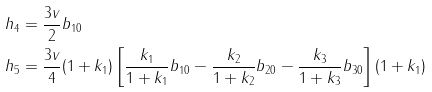Convert formula to latex. <formula><loc_0><loc_0><loc_500><loc_500>h _ { 4 } & = \frac { 3 v } { 2 } b _ { 1 0 } \\ h _ { 5 } & = \frac { 3 v } { 4 } ( 1 + k _ { 1 } ) \left [ \frac { k _ { 1 } } { 1 + k _ { 1 } } b _ { 1 0 } - \frac { k _ { 2 } } { 1 + k _ { 2 } } b _ { 2 0 } - \frac { k _ { 3 } } { 1 + k _ { 3 } } b _ { 3 0 } \right ] ( 1 + k _ { 1 } )</formula> 